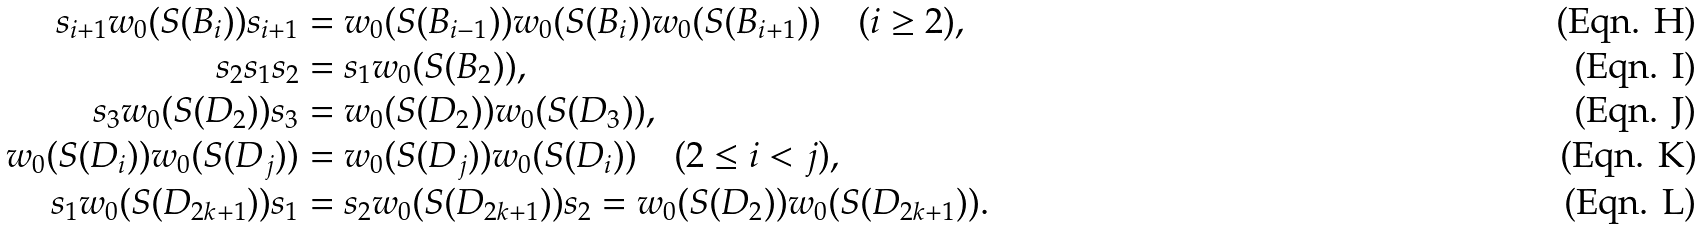<formula> <loc_0><loc_0><loc_500><loc_500>s _ { i + 1 } w _ { 0 } ( S ( B _ { i } ) ) s _ { i + 1 } & = w _ { 0 } ( S ( B _ { i - 1 } ) ) w _ { 0 } ( S ( B _ { i } ) ) w _ { 0 } ( S ( B _ { i + 1 } ) ) \quad ( i \geq 2 ) , \\ s _ { 2 } s _ { 1 } s _ { 2 } & = s _ { 1 } w _ { 0 } ( S ( B _ { 2 } ) ) , \\ s _ { 3 } w _ { 0 } ( S ( D _ { 2 } ) ) s _ { 3 } & = w _ { 0 } ( S ( D _ { 2 } ) ) w _ { 0 } ( S ( D _ { 3 } ) ) , \\ w _ { 0 } ( S ( D _ { i } ) ) w _ { 0 } ( S ( D _ { j } ) ) & = w _ { 0 } ( S ( D _ { j } ) ) w _ { 0 } ( S ( D _ { i } ) ) \quad ( 2 \leq i < j ) , \\ s _ { 1 } w _ { 0 } ( S ( D _ { 2 k + 1 } ) ) s _ { 1 } & = s _ { 2 } w _ { 0 } ( S ( D _ { 2 k + 1 } ) ) s _ { 2 } = w _ { 0 } ( S ( D _ { 2 } ) ) w _ { 0 } ( S ( D _ { 2 k + 1 } ) ) .</formula> 